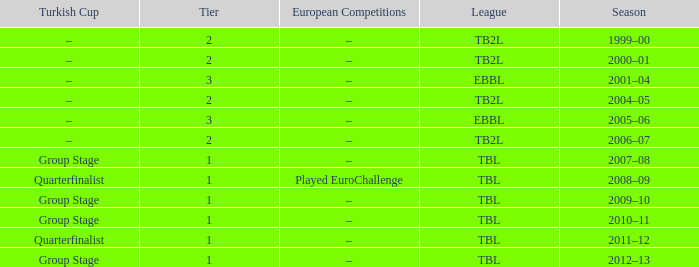Season of 2012–13 is what league? TBL. 